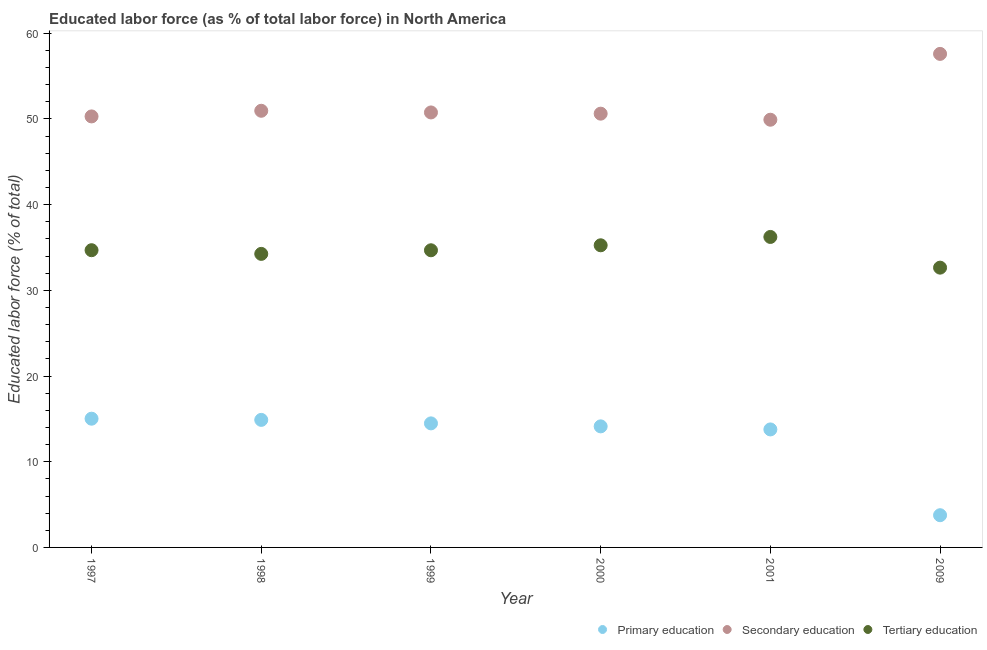How many different coloured dotlines are there?
Provide a succinct answer. 3. Is the number of dotlines equal to the number of legend labels?
Your response must be concise. Yes. What is the percentage of labor force who received secondary education in 1999?
Your response must be concise. 50.76. Across all years, what is the maximum percentage of labor force who received tertiary education?
Offer a terse response. 36.23. Across all years, what is the minimum percentage of labor force who received primary education?
Provide a short and direct response. 3.76. In which year was the percentage of labor force who received primary education maximum?
Your response must be concise. 1997. In which year was the percentage of labor force who received secondary education minimum?
Offer a very short reply. 2001. What is the total percentage of labor force who received tertiary education in the graph?
Your answer should be very brief. 207.75. What is the difference between the percentage of labor force who received secondary education in 2000 and that in 2001?
Ensure brevity in your answer.  0.71. What is the difference between the percentage of labor force who received secondary education in 2001 and the percentage of labor force who received primary education in 1999?
Your answer should be very brief. 35.43. What is the average percentage of labor force who received primary education per year?
Provide a succinct answer. 12.67. In the year 2000, what is the difference between the percentage of labor force who received secondary education and percentage of labor force who received tertiary education?
Ensure brevity in your answer.  15.36. In how many years, is the percentage of labor force who received tertiary education greater than 10 %?
Your answer should be compact. 6. What is the ratio of the percentage of labor force who received tertiary education in 2000 to that in 2009?
Your answer should be compact. 1.08. Is the difference between the percentage of labor force who received tertiary education in 2000 and 2001 greater than the difference between the percentage of labor force who received primary education in 2000 and 2001?
Provide a succinct answer. No. What is the difference between the highest and the second highest percentage of labor force who received primary education?
Make the answer very short. 0.14. What is the difference between the highest and the lowest percentage of labor force who received tertiary education?
Keep it short and to the point. 3.58. Does the percentage of labor force who received tertiary education monotonically increase over the years?
Provide a short and direct response. No. How many dotlines are there?
Your answer should be compact. 3. Does the graph contain any zero values?
Offer a very short reply. No. Does the graph contain grids?
Keep it short and to the point. No. Where does the legend appear in the graph?
Provide a succinct answer. Bottom right. How many legend labels are there?
Offer a very short reply. 3. How are the legend labels stacked?
Your answer should be very brief. Horizontal. What is the title of the graph?
Provide a succinct answer. Educated labor force (as % of total labor force) in North America. What is the label or title of the Y-axis?
Provide a short and direct response. Educated labor force (% of total). What is the Educated labor force (% of total) in Primary education in 1997?
Give a very brief answer. 15.02. What is the Educated labor force (% of total) of Secondary education in 1997?
Make the answer very short. 50.29. What is the Educated labor force (% of total) in Tertiary education in 1997?
Your answer should be compact. 34.68. What is the Educated labor force (% of total) of Primary education in 1998?
Give a very brief answer. 14.88. What is the Educated labor force (% of total) of Secondary education in 1998?
Keep it short and to the point. 50.95. What is the Educated labor force (% of total) of Tertiary education in 1998?
Ensure brevity in your answer.  34.25. What is the Educated labor force (% of total) in Primary education in 1999?
Provide a succinct answer. 14.48. What is the Educated labor force (% of total) of Secondary education in 1999?
Make the answer very short. 50.76. What is the Educated labor force (% of total) in Tertiary education in 1999?
Your answer should be very brief. 34.68. What is the Educated labor force (% of total) of Primary education in 2000?
Offer a very short reply. 14.13. What is the Educated labor force (% of total) of Secondary education in 2000?
Your answer should be very brief. 50.62. What is the Educated labor force (% of total) in Tertiary education in 2000?
Your response must be concise. 35.26. What is the Educated labor force (% of total) of Primary education in 2001?
Give a very brief answer. 13.77. What is the Educated labor force (% of total) in Secondary education in 2001?
Give a very brief answer. 49.91. What is the Educated labor force (% of total) in Tertiary education in 2001?
Offer a very short reply. 36.23. What is the Educated labor force (% of total) of Primary education in 2009?
Give a very brief answer. 3.76. What is the Educated labor force (% of total) of Secondary education in 2009?
Your response must be concise. 57.59. What is the Educated labor force (% of total) in Tertiary education in 2009?
Provide a succinct answer. 32.65. Across all years, what is the maximum Educated labor force (% of total) in Primary education?
Provide a succinct answer. 15.02. Across all years, what is the maximum Educated labor force (% of total) of Secondary education?
Your answer should be very brief. 57.59. Across all years, what is the maximum Educated labor force (% of total) of Tertiary education?
Keep it short and to the point. 36.23. Across all years, what is the minimum Educated labor force (% of total) in Primary education?
Keep it short and to the point. 3.76. Across all years, what is the minimum Educated labor force (% of total) in Secondary education?
Your answer should be compact. 49.91. Across all years, what is the minimum Educated labor force (% of total) of Tertiary education?
Give a very brief answer. 32.65. What is the total Educated labor force (% of total) of Primary education in the graph?
Offer a terse response. 76.04. What is the total Educated labor force (% of total) in Secondary education in the graph?
Offer a terse response. 310.12. What is the total Educated labor force (% of total) in Tertiary education in the graph?
Your answer should be compact. 207.75. What is the difference between the Educated labor force (% of total) of Primary education in 1997 and that in 1998?
Ensure brevity in your answer.  0.14. What is the difference between the Educated labor force (% of total) in Secondary education in 1997 and that in 1998?
Provide a succinct answer. -0.66. What is the difference between the Educated labor force (% of total) of Tertiary education in 1997 and that in 1998?
Offer a very short reply. 0.43. What is the difference between the Educated labor force (% of total) of Primary education in 1997 and that in 1999?
Your answer should be compact. 0.55. What is the difference between the Educated labor force (% of total) of Secondary education in 1997 and that in 1999?
Your answer should be compact. -0.46. What is the difference between the Educated labor force (% of total) in Tertiary education in 1997 and that in 1999?
Provide a short and direct response. 0.01. What is the difference between the Educated labor force (% of total) of Primary education in 1997 and that in 2000?
Your response must be concise. 0.89. What is the difference between the Educated labor force (% of total) in Secondary education in 1997 and that in 2000?
Your response must be concise. -0.32. What is the difference between the Educated labor force (% of total) in Tertiary education in 1997 and that in 2000?
Give a very brief answer. -0.57. What is the difference between the Educated labor force (% of total) in Primary education in 1997 and that in 2001?
Make the answer very short. 1.25. What is the difference between the Educated labor force (% of total) in Secondary education in 1997 and that in 2001?
Your answer should be very brief. 0.39. What is the difference between the Educated labor force (% of total) of Tertiary education in 1997 and that in 2001?
Keep it short and to the point. -1.55. What is the difference between the Educated labor force (% of total) of Primary education in 1997 and that in 2009?
Give a very brief answer. 11.26. What is the difference between the Educated labor force (% of total) in Secondary education in 1997 and that in 2009?
Keep it short and to the point. -7.3. What is the difference between the Educated labor force (% of total) in Tertiary education in 1997 and that in 2009?
Your answer should be very brief. 2.04. What is the difference between the Educated labor force (% of total) of Primary education in 1998 and that in 1999?
Make the answer very short. 0.41. What is the difference between the Educated labor force (% of total) in Secondary education in 1998 and that in 1999?
Your response must be concise. 0.19. What is the difference between the Educated labor force (% of total) in Tertiary education in 1998 and that in 1999?
Your answer should be very brief. -0.42. What is the difference between the Educated labor force (% of total) of Primary education in 1998 and that in 2000?
Offer a very short reply. 0.76. What is the difference between the Educated labor force (% of total) in Secondary education in 1998 and that in 2000?
Give a very brief answer. 0.34. What is the difference between the Educated labor force (% of total) of Tertiary education in 1998 and that in 2000?
Keep it short and to the point. -1. What is the difference between the Educated labor force (% of total) in Primary education in 1998 and that in 2001?
Keep it short and to the point. 1.11. What is the difference between the Educated labor force (% of total) of Secondary education in 1998 and that in 2001?
Keep it short and to the point. 1.04. What is the difference between the Educated labor force (% of total) in Tertiary education in 1998 and that in 2001?
Ensure brevity in your answer.  -1.98. What is the difference between the Educated labor force (% of total) in Primary education in 1998 and that in 2009?
Provide a short and direct response. 11.12. What is the difference between the Educated labor force (% of total) in Secondary education in 1998 and that in 2009?
Make the answer very short. -6.64. What is the difference between the Educated labor force (% of total) in Tertiary education in 1998 and that in 2009?
Provide a short and direct response. 1.61. What is the difference between the Educated labor force (% of total) of Primary education in 1999 and that in 2000?
Your response must be concise. 0.35. What is the difference between the Educated labor force (% of total) of Secondary education in 1999 and that in 2000?
Your answer should be very brief. 0.14. What is the difference between the Educated labor force (% of total) of Tertiary education in 1999 and that in 2000?
Offer a very short reply. -0.58. What is the difference between the Educated labor force (% of total) in Primary education in 1999 and that in 2001?
Your response must be concise. 0.71. What is the difference between the Educated labor force (% of total) in Secondary education in 1999 and that in 2001?
Your answer should be compact. 0.85. What is the difference between the Educated labor force (% of total) of Tertiary education in 1999 and that in 2001?
Provide a short and direct response. -1.55. What is the difference between the Educated labor force (% of total) in Primary education in 1999 and that in 2009?
Offer a terse response. 10.72. What is the difference between the Educated labor force (% of total) of Secondary education in 1999 and that in 2009?
Give a very brief answer. -6.83. What is the difference between the Educated labor force (% of total) in Tertiary education in 1999 and that in 2009?
Provide a succinct answer. 2.03. What is the difference between the Educated labor force (% of total) in Primary education in 2000 and that in 2001?
Keep it short and to the point. 0.36. What is the difference between the Educated labor force (% of total) of Secondary education in 2000 and that in 2001?
Your answer should be very brief. 0.71. What is the difference between the Educated labor force (% of total) of Tertiary education in 2000 and that in 2001?
Give a very brief answer. -0.97. What is the difference between the Educated labor force (% of total) in Primary education in 2000 and that in 2009?
Your response must be concise. 10.37. What is the difference between the Educated labor force (% of total) in Secondary education in 2000 and that in 2009?
Your answer should be very brief. -6.98. What is the difference between the Educated labor force (% of total) of Tertiary education in 2000 and that in 2009?
Your answer should be compact. 2.61. What is the difference between the Educated labor force (% of total) in Primary education in 2001 and that in 2009?
Your answer should be very brief. 10.01. What is the difference between the Educated labor force (% of total) of Secondary education in 2001 and that in 2009?
Ensure brevity in your answer.  -7.68. What is the difference between the Educated labor force (% of total) in Tertiary education in 2001 and that in 2009?
Provide a succinct answer. 3.58. What is the difference between the Educated labor force (% of total) in Primary education in 1997 and the Educated labor force (% of total) in Secondary education in 1998?
Offer a very short reply. -35.93. What is the difference between the Educated labor force (% of total) in Primary education in 1997 and the Educated labor force (% of total) in Tertiary education in 1998?
Offer a very short reply. -19.23. What is the difference between the Educated labor force (% of total) of Secondary education in 1997 and the Educated labor force (% of total) of Tertiary education in 1998?
Offer a terse response. 16.04. What is the difference between the Educated labor force (% of total) in Primary education in 1997 and the Educated labor force (% of total) in Secondary education in 1999?
Provide a succinct answer. -35.74. What is the difference between the Educated labor force (% of total) of Primary education in 1997 and the Educated labor force (% of total) of Tertiary education in 1999?
Your response must be concise. -19.65. What is the difference between the Educated labor force (% of total) in Secondary education in 1997 and the Educated labor force (% of total) in Tertiary education in 1999?
Keep it short and to the point. 15.62. What is the difference between the Educated labor force (% of total) of Primary education in 1997 and the Educated labor force (% of total) of Secondary education in 2000?
Your answer should be compact. -35.59. What is the difference between the Educated labor force (% of total) in Primary education in 1997 and the Educated labor force (% of total) in Tertiary education in 2000?
Offer a very short reply. -20.24. What is the difference between the Educated labor force (% of total) of Secondary education in 1997 and the Educated labor force (% of total) of Tertiary education in 2000?
Provide a succinct answer. 15.04. What is the difference between the Educated labor force (% of total) of Primary education in 1997 and the Educated labor force (% of total) of Secondary education in 2001?
Your response must be concise. -34.89. What is the difference between the Educated labor force (% of total) of Primary education in 1997 and the Educated labor force (% of total) of Tertiary education in 2001?
Give a very brief answer. -21.21. What is the difference between the Educated labor force (% of total) of Secondary education in 1997 and the Educated labor force (% of total) of Tertiary education in 2001?
Give a very brief answer. 14.06. What is the difference between the Educated labor force (% of total) of Primary education in 1997 and the Educated labor force (% of total) of Secondary education in 2009?
Your answer should be very brief. -42.57. What is the difference between the Educated labor force (% of total) of Primary education in 1997 and the Educated labor force (% of total) of Tertiary education in 2009?
Ensure brevity in your answer.  -17.63. What is the difference between the Educated labor force (% of total) in Secondary education in 1997 and the Educated labor force (% of total) in Tertiary education in 2009?
Give a very brief answer. 17.65. What is the difference between the Educated labor force (% of total) in Primary education in 1998 and the Educated labor force (% of total) in Secondary education in 1999?
Offer a very short reply. -35.88. What is the difference between the Educated labor force (% of total) in Primary education in 1998 and the Educated labor force (% of total) in Tertiary education in 1999?
Your answer should be compact. -19.79. What is the difference between the Educated labor force (% of total) in Secondary education in 1998 and the Educated labor force (% of total) in Tertiary education in 1999?
Provide a short and direct response. 16.28. What is the difference between the Educated labor force (% of total) in Primary education in 1998 and the Educated labor force (% of total) in Secondary education in 2000?
Ensure brevity in your answer.  -35.73. What is the difference between the Educated labor force (% of total) in Primary education in 1998 and the Educated labor force (% of total) in Tertiary education in 2000?
Your answer should be very brief. -20.37. What is the difference between the Educated labor force (% of total) of Secondary education in 1998 and the Educated labor force (% of total) of Tertiary education in 2000?
Your response must be concise. 15.7. What is the difference between the Educated labor force (% of total) in Primary education in 1998 and the Educated labor force (% of total) in Secondary education in 2001?
Make the answer very short. -35.03. What is the difference between the Educated labor force (% of total) of Primary education in 1998 and the Educated labor force (% of total) of Tertiary education in 2001?
Your answer should be very brief. -21.35. What is the difference between the Educated labor force (% of total) of Secondary education in 1998 and the Educated labor force (% of total) of Tertiary education in 2001?
Offer a terse response. 14.72. What is the difference between the Educated labor force (% of total) in Primary education in 1998 and the Educated labor force (% of total) in Secondary education in 2009?
Your answer should be compact. -42.71. What is the difference between the Educated labor force (% of total) of Primary education in 1998 and the Educated labor force (% of total) of Tertiary education in 2009?
Your answer should be compact. -17.76. What is the difference between the Educated labor force (% of total) in Secondary education in 1998 and the Educated labor force (% of total) in Tertiary education in 2009?
Offer a terse response. 18.31. What is the difference between the Educated labor force (% of total) of Primary education in 1999 and the Educated labor force (% of total) of Secondary education in 2000?
Offer a very short reply. -36.14. What is the difference between the Educated labor force (% of total) in Primary education in 1999 and the Educated labor force (% of total) in Tertiary education in 2000?
Make the answer very short. -20.78. What is the difference between the Educated labor force (% of total) in Secondary education in 1999 and the Educated labor force (% of total) in Tertiary education in 2000?
Provide a short and direct response. 15.5. What is the difference between the Educated labor force (% of total) of Primary education in 1999 and the Educated labor force (% of total) of Secondary education in 2001?
Offer a terse response. -35.43. What is the difference between the Educated labor force (% of total) of Primary education in 1999 and the Educated labor force (% of total) of Tertiary education in 2001?
Offer a terse response. -21.75. What is the difference between the Educated labor force (% of total) of Secondary education in 1999 and the Educated labor force (% of total) of Tertiary education in 2001?
Offer a terse response. 14.53. What is the difference between the Educated labor force (% of total) of Primary education in 1999 and the Educated labor force (% of total) of Secondary education in 2009?
Provide a succinct answer. -43.12. What is the difference between the Educated labor force (% of total) in Primary education in 1999 and the Educated labor force (% of total) in Tertiary education in 2009?
Give a very brief answer. -18.17. What is the difference between the Educated labor force (% of total) of Secondary education in 1999 and the Educated labor force (% of total) of Tertiary education in 2009?
Offer a very short reply. 18.11. What is the difference between the Educated labor force (% of total) of Primary education in 2000 and the Educated labor force (% of total) of Secondary education in 2001?
Offer a very short reply. -35.78. What is the difference between the Educated labor force (% of total) in Primary education in 2000 and the Educated labor force (% of total) in Tertiary education in 2001?
Your response must be concise. -22.1. What is the difference between the Educated labor force (% of total) of Secondary education in 2000 and the Educated labor force (% of total) of Tertiary education in 2001?
Your answer should be very brief. 14.39. What is the difference between the Educated labor force (% of total) of Primary education in 2000 and the Educated labor force (% of total) of Secondary education in 2009?
Keep it short and to the point. -43.46. What is the difference between the Educated labor force (% of total) of Primary education in 2000 and the Educated labor force (% of total) of Tertiary education in 2009?
Give a very brief answer. -18.52. What is the difference between the Educated labor force (% of total) in Secondary education in 2000 and the Educated labor force (% of total) in Tertiary education in 2009?
Your response must be concise. 17.97. What is the difference between the Educated labor force (% of total) in Primary education in 2001 and the Educated labor force (% of total) in Secondary education in 2009?
Offer a terse response. -43.82. What is the difference between the Educated labor force (% of total) in Primary education in 2001 and the Educated labor force (% of total) in Tertiary education in 2009?
Give a very brief answer. -18.88. What is the difference between the Educated labor force (% of total) in Secondary education in 2001 and the Educated labor force (% of total) in Tertiary education in 2009?
Provide a short and direct response. 17.26. What is the average Educated labor force (% of total) in Primary education per year?
Give a very brief answer. 12.67. What is the average Educated labor force (% of total) in Secondary education per year?
Offer a terse response. 51.69. What is the average Educated labor force (% of total) in Tertiary education per year?
Your answer should be very brief. 34.62. In the year 1997, what is the difference between the Educated labor force (% of total) of Primary education and Educated labor force (% of total) of Secondary education?
Your answer should be compact. -35.27. In the year 1997, what is the difference between the Educated labor force (% of total) in Primary education and Educated labor force (% of total) in Tertiary education?
Your answer should be very brief. -19.66. In the year 1997, what is the difference between the Educated labor force (% of total) in Secondary education and Educated labor force (% of total) in Tertiary education?
Ensure brevity in your answer.  15.61. In the year 1998, what is the difference between the Educated labor force (% of total) in Primary education and Educated labor force (% of total) in Secondary education?
Give a very brief answer. -36.07. In the year 1998, what is the difference between the Educated labor force (% of total) in Primary education and Educated labor force (% of total) in Tertiary education?
Keep it short and to the point. -19.37. In the year 1998, what is the difference between the Educated labor force (% of total) in Secondary education and Educated labor force (% of total) in Tertiary education?
Keep it short and to the point. 16.7. In the year 1999, what is the difference between the Educated labor force (% of total) in Primary education and Educated labor force (% of total) in Secondary education?
Keep it short and to the point. -36.28. In the year 1999, what is the difference between the Educated labor force (% of total) in Primary education and Educated labor force (% of total) in Tertiary education?
Offer a terse response. -20.2. In the year 1999, what is the difference between the Educated labor force (% of total) of Secondary education and Educated labor force (% of total) of Tertiary education?
Your response must be concise. 16.08. In the year 2000, what is the difference between the Educated labor force (% of total) of Primary education and Educated labor force (% of total) of Secondary education?
Your answer should be very brief. -36.49. In the year 2000, what is the difference between the Educated labor force (% of total) of Primary education and Educated labor force (% of total) of Tertiary education?
Offer a very short reply. -21.13. In the year 2000, what is the difference between the Educated labor force (% of total) in Secondary education and Educated labor force (% of total) in Tertiary education?
Your answer should be very brief. 15.36. In the year 2001, what is the difference between the Educated labor force (% of total) of Primary education and Educated labor force (% of total) of Secondary education?
Your answer should be very brief. -36.14. In the year 2001, what is the difference between the Educated labor force (% of total) in Primary education and Educated labor force (% of total) in Tertiary education?
Keep it short and to the point. -22.46. In the year 2001, what is the difference between the Educated labor force (% of total) in Secondary education and Educated labor force (% of total) in Tertiary education?
Offer a terse response. 13.68. In the year 2009, what is the difference between the Educated labor force (% of total) of Primary education and Educated labor force (% of total) of Secondary education?
Provide a succinct answer. -53.83. In the year 2009, what is the difference between the Educated labor force (% of total) in Primary education and Educated labor force (% of total) in Tertiary education?
Offer a terse response. -28.89. In the year 2009, what is the difference between the Educated labor force (% of total) of Secondary education and Educated labor force (% of total) of Tertiary education?
Make the answer very short. 24.94. What is the ratio of the Educated labor force (% of total) of Primary education in 1997 to that in 1998?
Give a very brief answer. 1.01. What is the ratio of the Educated labor force (% of total) in Secondary education in 1997 to that in 1998?
Offer a very short reply. 0.99. What is the ratio of the Educated labor force (% of total) of Tertiary education in 1997 to that in 1998?
Your response must be concise. 1.01. What is the ratio of the Educated labor force (% of total) in Primary education in 1997 to that in 1999?
Ensure brevity in your answer.  1.04. What is the ratio of the Educated labor force (% of total) of Secondary education in 1997 to that in 1999?
Your response must be concise. 0.99. What is the ratio of the Educated labor force (% of total) of Tertiary education in 1997 to that in 1999?
Ensure brevity in your answer.  1. What is the ratio of the Educated labor force (% of total) in Primary education in 1997 to that in 2000?
Your answer should be very brief. 1.06. What is the ratio of the Educated labor force (% of total) of Secondary education in 1997 to that in 2000?
Your response must be concise. 0.99. What is the ratio of the Educated labor force (% of total) of Tertiary education in 1997 to that in 2000?
Give a very brief answer. 0.98. What is the ratio of the Educated labor force (% of total) of Secondary education in 1997 to that in 2001?
Give a very brief answer. 1.01. What is the ratio of the Educated labor force (% of total) in Tertiary education in 1997 to that in 2001?
Ensure brevity in your answer.  0.96. What is the ratio of the Educated labor force (% of total) in Primary education in 1997 to that in 2009?
Offer a very short reply. 4. What is the ratio of the Educated labor force (% of total) in Secondary education in 1997 to that in 2009?
Provide a succinct answer. 0.87. What is the ratio of the Educated labor force (% of total) in Tertiary education in 1997 to that in 2009?
Provide a short and direct response. 1.06. What is the ratio of the Educated labor force (% of total) in Primary education in 1998 to that in 1999?
Provide a short and direct response. 1.03. What is the ratio of the Educated labor force (% of total) in Tertiary education in 1998 to that in 1999?
Give a very brief answer. 0.99. What is the ratio of the Educated labor force (% of total) of Primary education in 1998 to that in 2000?
Ensure brevity in your answer.  1.05. What is the ratio of the Educated labor force (% of total) of Tertiary education in 1998 to that in 2000?
Keep it short and to the point. 0.97. What is the ratio of the Educated labor force (% of total) in Primary education in 1998 to that in 2001?
Make the answer very short. 1.08. What is the ratio of the Educated labor force (% of total) in Secondary education in 1998 to that in 2001?
Ensure brevity in your answer.  1.02. What is the ratio of the Educated labor force (% of total) of Tertiary education in 1998 to that in 2001?
Give a very brief answer. 0.95. What is the ratio of the Educated labor force (% of total) of Primary education in 1998 to that in 2009?
Ensure brevity in your answer.  3.96. What is the ratio of the Educated labor force (% of total) in Secondary education in 1998 to that in 2009?
Ensure brevity in your answer.  0.88. What is the ratio of the Educated labor force (% of total) of Tertiary education in 1998 to that in 2009?
Your response must be concise. 1.05. What is the ratio of the Educated labor force (% of total) in Primary education in 1999 to that in 2000?
Give a very brief answer. 1.02. What is the ratio of the Educated labor force (% of total) of Secondary education in 1999 to that in 2000?
Provide a succinct answer. 1. What is the ratio of the Educated labor force (% of total) in Tertiary education in 1999 to that in 2000?
Make the answer very short. 0.98. What is the ratio of the Educated labor force (% of total) in Primary education in 1999 to that in 2001?
Your answer should be very brief. 1.05. What is the ratio of the Educated labor force (% of total) of Tertiary education in 1999 to that in 2001?
Your answer should be compact. 0.96. What is the ratio of the Educated labor force (% of total) in Primary education in 1999 to that in 2009?
Offer a terse response. 3.85. What is the ratio of the Educated labor force (% of total) in Secondary education in 1999 to that in 2009?
Ensure brevity in your answer.  0.88. What is the ratio of the Educated labor force (% of total) of Tertiary education in 1999 to that in 2009?
Ensure brevity in your answer.  1.06. What is the ratio of the Educated labor force (% of total) in Primary education in 2000 to that in 2001?
Provide a succinct answer. 1.03. What is the ratio of the Educated labor force (% of total) of Secondary education in 2000 to that in 2001?
Offer a terse response. 1.01. What is the ratio of the Educated labor force (% of total) of Tertiary education in 2000 to that in 2001?
Your answer should be very brief. 0.97. What is the ratio of the Educated labor force (% of total) of Primary education in 2000 to that in 2009?
Make the answer very short. 3.76. What is the ratio of the Educated labor force (% of total) in Secondary education in 2000 to that in 2009?
Ensure brevity in your answer.  0.88. What is the ratio of the Educated labor force (% of total) of Tertiary education in 2000 to that in 2009?
Give a very brief answer. 1.08. What is the ratio of the Educated labor force (% of total) of Primary education in 2001 to that in 2009?
Make the answer very short. 3.66. What is the ratio of the Educated labor force (% of total) in Secondary education in 2001 to that in 2009?
Ensure brevity in your answer.  0.87. What is the ratio of the Educated labor force (% of total) of Tertiary education in 2001 to that in 2009?
Your answer should be compact. 1.11. What is the difference between the highest and the second highest Educated labor force (% of total) in Primary education?
Provide a short and direct response. 0.14. What is the difference between the highest and the second highest Educated labor force (% of total) of Secondary education?
Provide a short and direct response. 6.64. What is the difference between the highest and the second highest Educated labor force (% of total) of Tertiary education?
Keep it short and to the point. 0.97. What is the difference between the highest and the lowest Educated labor force (% of total) in Primary education?
Provide a succinct answer. 11.26. What is the difference between the highest and the lowest Educated labor force (% of total) in Secondary education?
Your response must be concise. 7.68. What is the difference between the highest and the lowest Educated labor force (% of total) of Tertiary education?
Your answer should be compact. 3.58. 